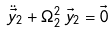<formula> <loc_0><loc_0><loc_500><loc_500>\ddot { \vec { y } } _ { 2 } + \Omega _ { 2 } ^ { 2 } \, \vec { y } _ { 2 } = \vec { 0 }</formula> 